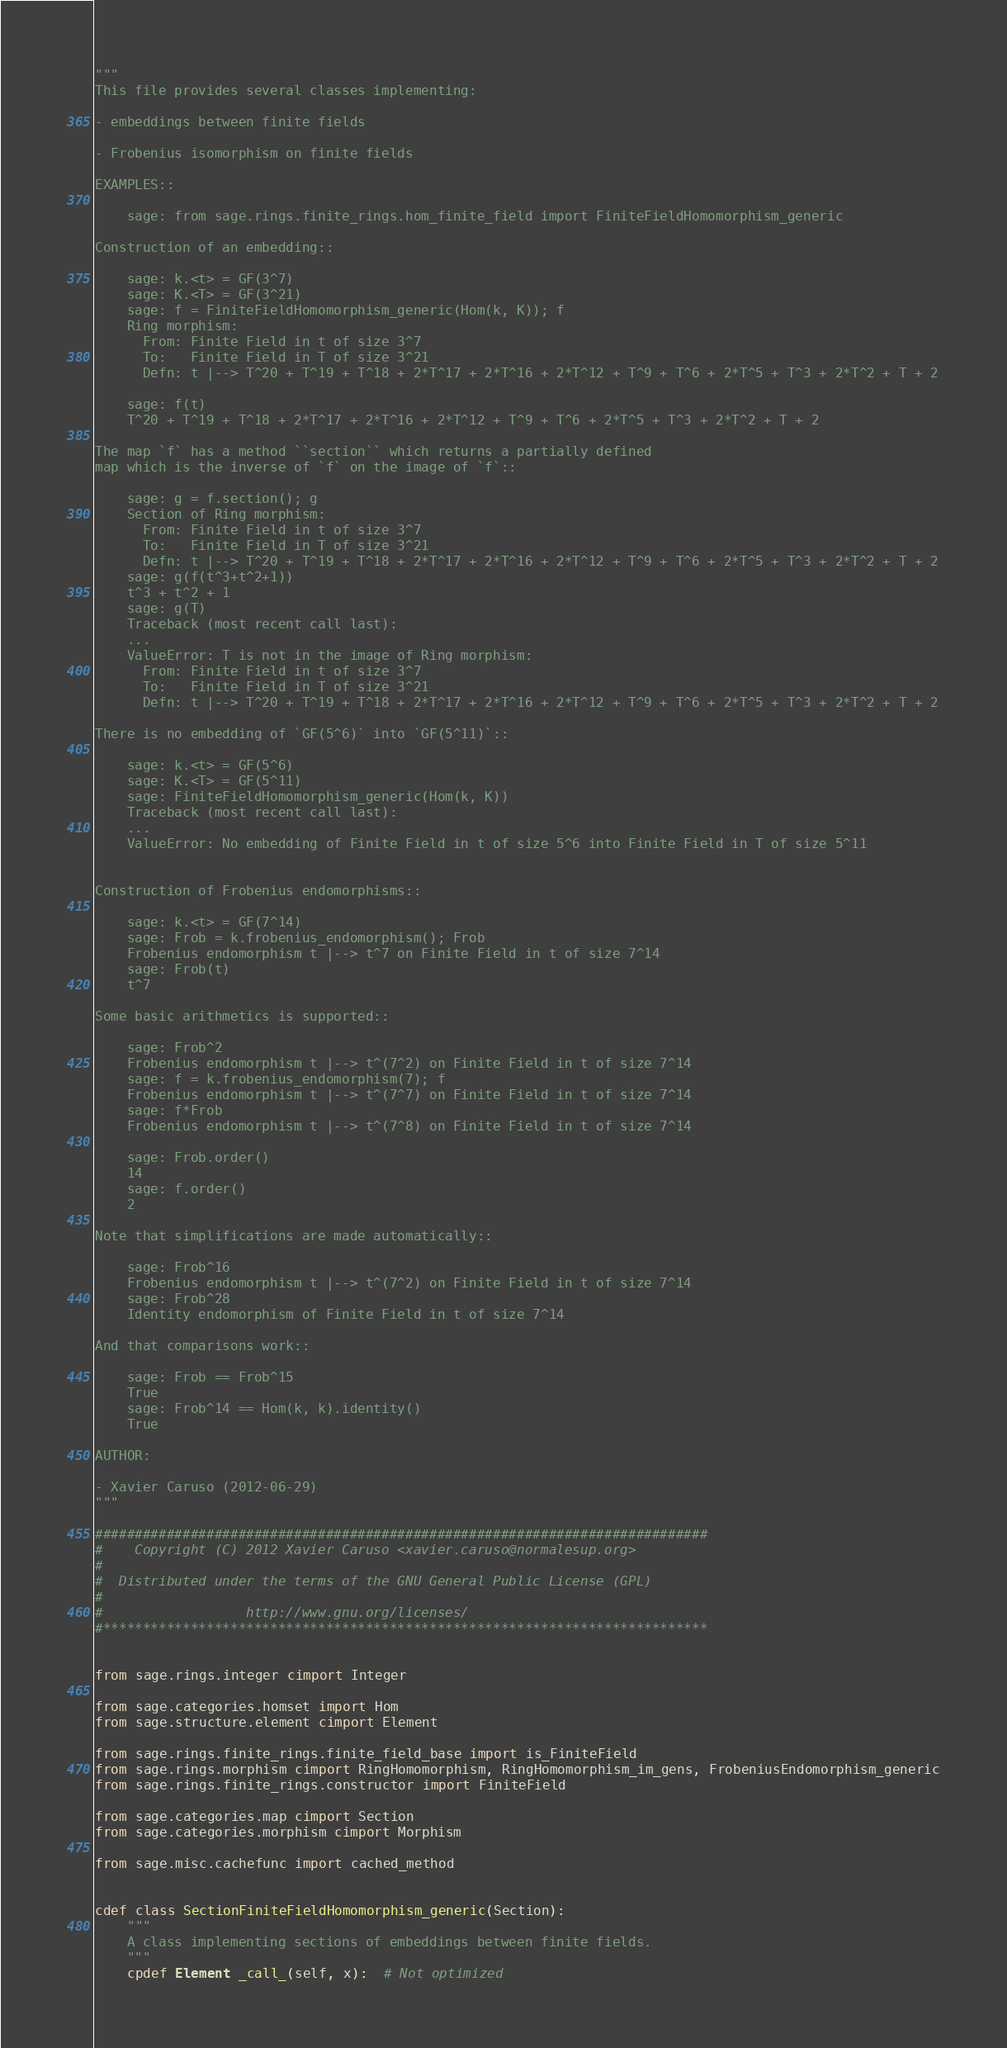Convert code to text. <code><loc_0><loc_0><loc_500><loc_500><_Cython_>"""
This file provides several classes implementing:

- embeddings between finite fields

- Frobenius isomorphism on finite fields

EXAMPLES::

    sage: from sage.rings.finite_rings.hom_finite_field import FiniteFieldHomomorphism_generic

Construction of an embedding::

    sage: k.<t> = GF(3^7)
    sage: K.<T> = GF(3^21)
    sage: f = FiniteFieldHomomorphism_generic(Hom(k, K)); f
    Ring morphism:
      From: Finite Field in t of size 3^7
      To:   Finite Field in T of size 3^21
      Defn: t |--> T^20 + T^19 + T^18 + 2*T^17 + 2*T^16 + 2*T^12 + T^9 + T^6 + 2*T^5 + T^3 + 2*T^2 + T + 2

    sage: f(t)
    T^20 + T^19 + T^18 + 2*T^17 + 2*T^16 + 2*T^12 + T^9 + T^6 + 2*T^5 + T^3 + 2*T^2 + T + 2

The map `f` has a method ``section`` which returns a partially defined
map which is the inverse of `f` on the image of `f`::

    sage: g = f.section(); g
    Section of Ring morphism:
      From: Finite Field in t of size 3^7
      To:   Finite Field in T of size 3^21
      Defn: t |--> T^20 + T^19 + T^18 + 2*T^17 + 2*T^16 + 2*T^12 + T^9 + T^6 + 2*T^5 + T^3 + 2*T^2 + T + 2
    sage: g(f(t^3+t^2+1))
    t^3 + t^2 + 1
    sage: g(T)
    Traceback (most recent call last):
    ...
    ValueError: T is not in the image of Ring morphism:
      From: Finite Field in t of size 3^7
      To:   Finite Field in T of size 3^21
      Defn: t |--> T^20 + T^19 + T^18 + 2*T^17 + 2*T^16 + 2*T^12 + T^9 + T^6 + 2*T^5 + T^3 + 2*T^2 + T + 2

There is no embedding of `GF(5^6)` into `GF(5^11)`::

    sage: k.<t> = GF(5^6)
    sage: K.<T> = GF(5^11)
    sage: FiniteFieldHomomorphism_generic(Hom(k, K))
    Traceback (most recent call last):
    ...
    ValueError: No embedding of Finite Field in t of size 5^6 into Finite Field in T of size 5^11


Construction of Frobenius endomorphisms::

    sage: k.<t> = GF(7^14)
    sage: Frob = k.frobenius_endomorphism(); Frob
    Frobenius endomorphism t |--> t^7 on Finite Field in t of size 7^14
    sage: Frob(t)
    t^7

Some basic arithmetics is supported::

    sage: Frob^2
    Frobenius endomorphism t |--> t^(7^2) on Finite Field in t of size 7^14
    sage: f = k.frobenius_endomorphism(7); f
    Frobenius endomorphism t |--> t^(7^7) on Finite Field in t of size 7^14
    sage: f*Frob
    Frobenius endomorphism t |--> t^(7^8) on Finite Field in t of size 7^14

    sage: Frob.order()
    14
    sage: f.order()
    2

Note that simplifications are made automatically::

    sage: Frob^16
    Frobenius endomorphism t |--> t^(7^2) on Finite Field in t of size 7^14
    sage: Frob^28
    Identity endomorphism of Finite Field in t of size 7^14

And that comparisons work::

    sage: Frob == Frob^15
    True
    sage: Frob^14 == Hom(k, k).identity()
    True

AUTHOR:

- Xavier Caruso (2012-06-29)
"""

#############################################################################
#    Copyright (C) 2012 Xavier Caruso <xavier.caruso@normalesup.org>
#
#  Distributed under the terms of the GNU General Public License (GPL)
#
#                  http://www.gnu.org/licenses/
#****************************************************************************


from sage.rings.integer cimport Integer

from sage.categories.homset import Hom
from sage.structure.element cimport Element

from sage.rings.finite_rings.finite_field_base import is_FiniteField
from sage.rings.morphism cimport RingHomomorphism, RingHomomorphism_im_gens, FrobeniusEndomorphism_generic
from sage.rings.finite_rings.constructor import FiniteField

from sage.categories.map cimport Section
from sage.categories.morphism cimport Morphism

from sage.misc.cachefunc import cached_method


cdef class SectionFiniteFieldHomomorphism_generic(Section):
    """
    A class implementing sections of embeddings between finite fields.
    """
    cpdef Element _call_(self, x):  # Not optimized</code> 